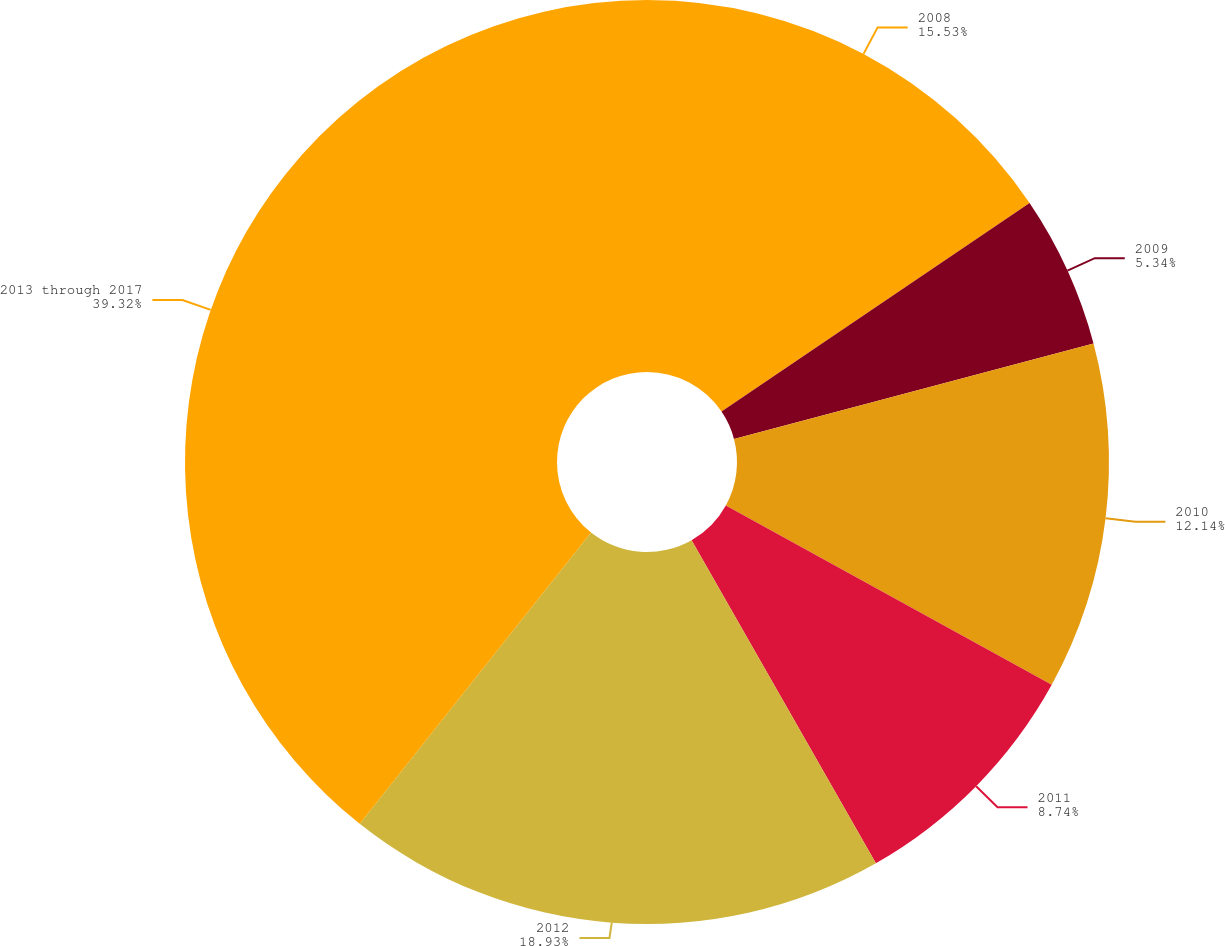<chart> <loc_0><loc_0><loc_500><loc_500><pie_chart><fcel>2008<fcel>2009<fcel>2010<fcel>2011<fcel>2012<fcel>2013 through 2017<nl><fcel>15.53%<fcel>5.34%<fcel>12.14%<fcel>8.74%<fcel>18.93%<fcel>39.32%<nl></chart> 